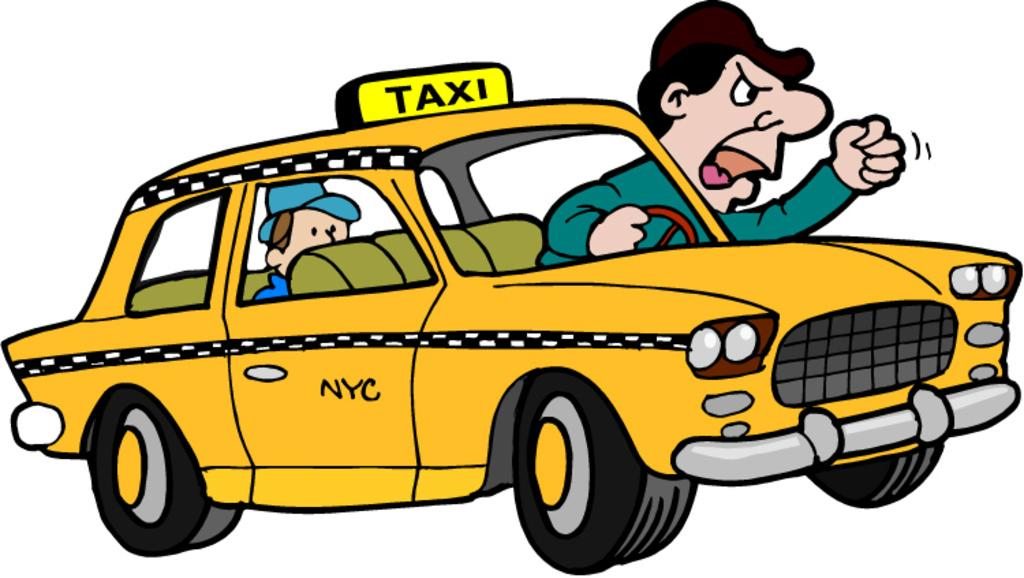<image>
Render a clear and concise summary of the photo. A taxi driver is leaning out of his car and yellowing and the side of the taxi says NYC. 